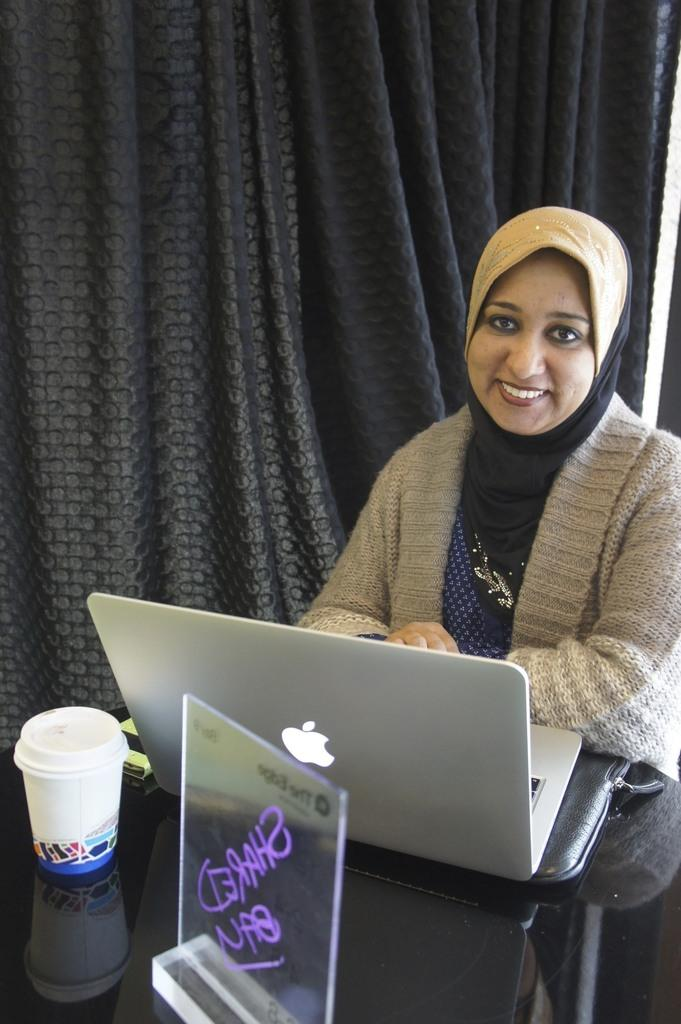What objects are located at the bottom of the image? There is a laptop, a cup, a mobile, a memorandum, and a table at the bottom of the image. What is the woman in the middle of the image doing? The provided facts do not specify what the woman is doing in the image. What can be seen at the top of the image? There are curtains at the top of the image. What type of business is being conducted in the image? There is no indication of any business being conducted in the image. Can you see a bear in the image? No, there is no bear present in the image. 